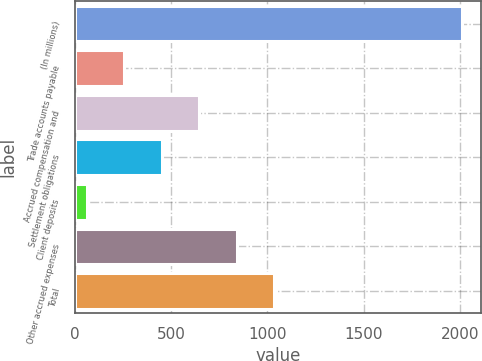<chart> <loc_0><loc_0><loc_500><loc_500><bar_chart><fcel>(In millions)<fcel>Trade accounts payable<fcel>Accrued compensation and<fcel>Settlement obligations<fcel>Client deposits<fcel>Other accrued expenses<fcel>Total<nl><fcel>2010<fcel>257.7<fcel>647.1<fcel>452.4<fcel>63<fcel>841.8<fcel>1036.5<nl></chart> 